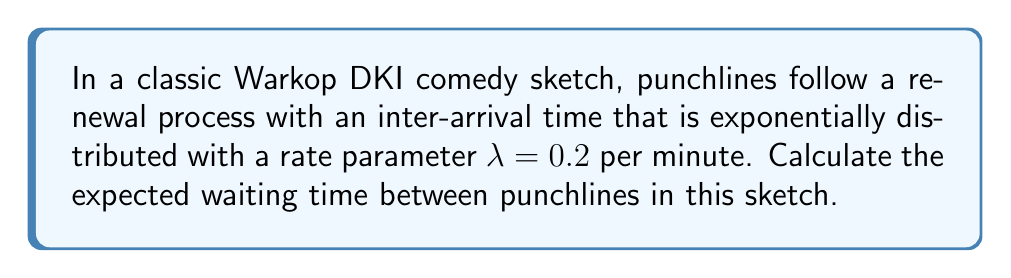Teach me how to tackle this problem. To solve this problem, we'll use the properties of renewal processes and exponential distributions:

1. In a renewal process with exponentially distributed inter-arrival times, the expected waiting time between events is equal to the mean of the exponential distribution.

2. For an exponential distribution with rate parameter $\lambda$, the mean (expected value) is given by:

   $$E[X] = \frac{1}{\lambda}$$

3. In this case, $\lambda = 0.2$ per minute.

4. Substituting this value into the formula:

   $$E[X] = \frac{1}{0.2} = 5$$

5. Therefore, the expected waiting time between punchlines is 5 minutes.

This result means that, on average, you can expect a punchline every 5 minutes in this Warkop DKI comedy sketch.
Answer: 5 minutes 